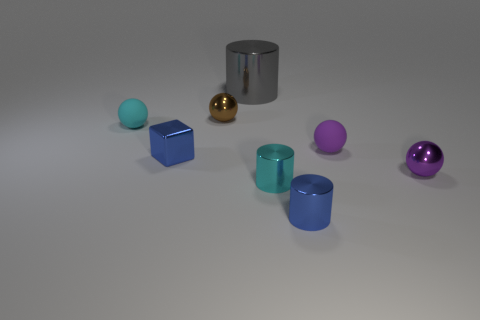Subtract all purple matte balls. How many balls are left? 3 Subtract all blue cylinders. How many cylinders are left? 2 Subtract all cubes. How many objects are left? 7 Subtract 1 cylinders. How many cylinders are left? 2 Subtract all red spheres. How many gray cubes are left? 0 Subtract all small purple shiny objects. Subtract all small cyan balls. How many objects are left? 6 Add 6 tiny purple rubber objects. How many tiny purple rubber objects are left? 7 Add 4 gray cylinders. How many gray cylinders exist? 5 Add 1 big gray cylinders. How many objects exist? 9 Subtract 2 purple spheres. How many objects are left? 6 